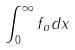Convert formula to latex. <formula><loc_0><loc_0><loc_500><loc_500>\int _ { 0 } ^ { \infty } f _ { a } d x</formula> 